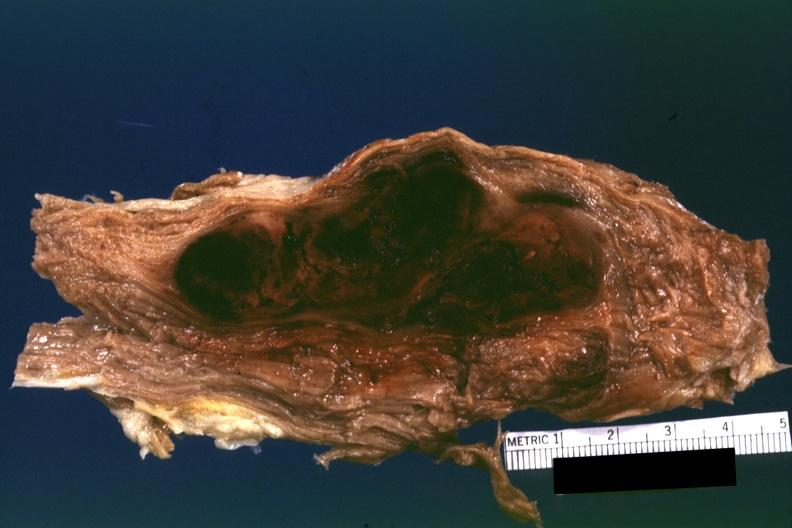what does this appear?
Answer the question using a single word or phrase. To be in a psoas muscle if so the diagnosis on all other slides of case in file needs to be changed 